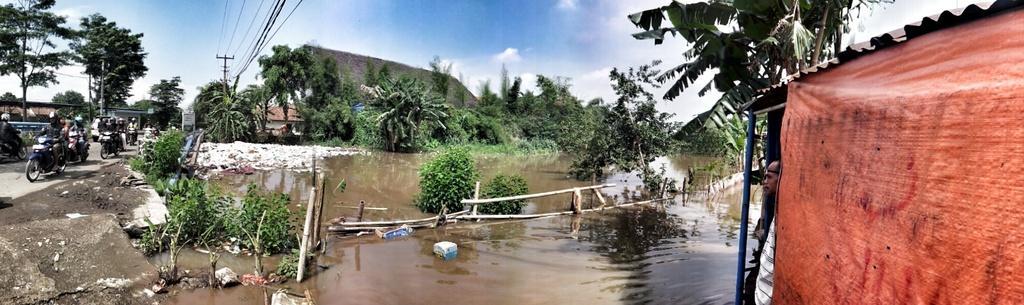How would you summarize this image in a sentence or two? In this image we can see a lake. There are few vehicles are moving on the road. There are many trees and plants in the image. There is a blue and cloudy sky in the image. There are few houses in the image. 